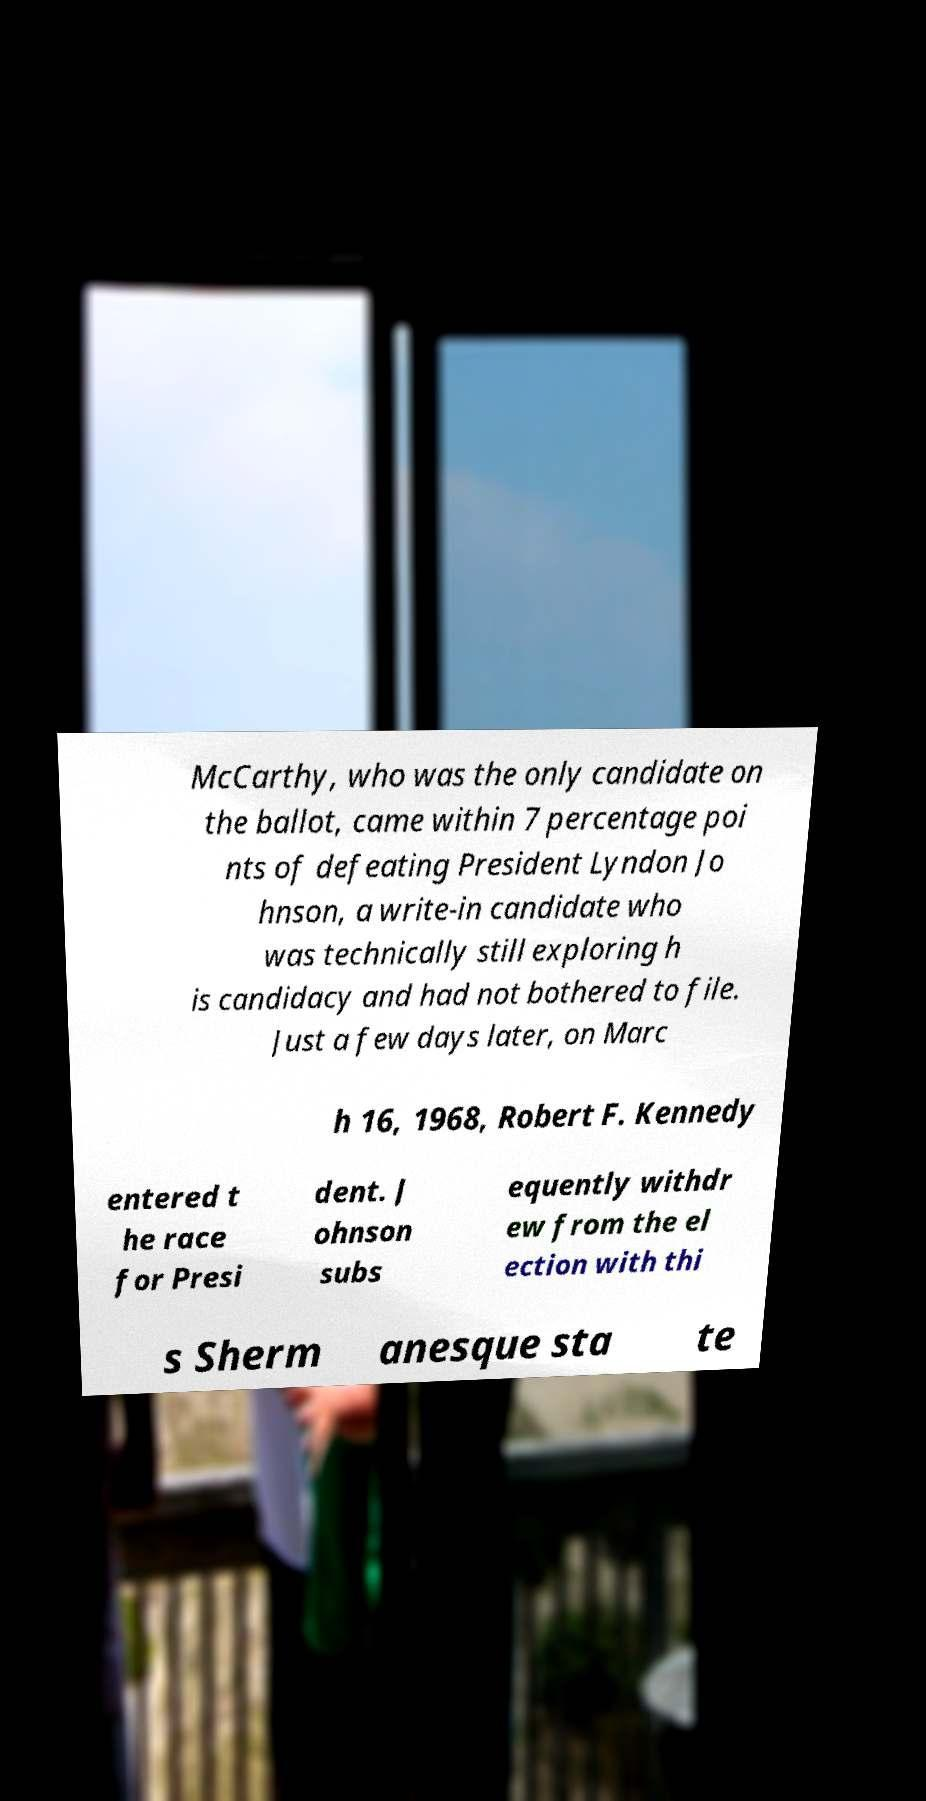Can you read and provide the text displayed in the image?This photo seems to have some interesting text. Can you extract and type it out for me? McCarthy, who was the only candidate on the ballot, came within 7 percentage poi nts of defeating President Lyndon Jo hnson, a write-in candidate who was technically still exploring h is candidacy and had not bothered to file. Just a few days later, on Marc h 16, 1968, Robert F. Kennedy entered t he race for Presi dent. J ohnson subs equently withdr ew from the el ection with thi s Sherm anesque sta te 